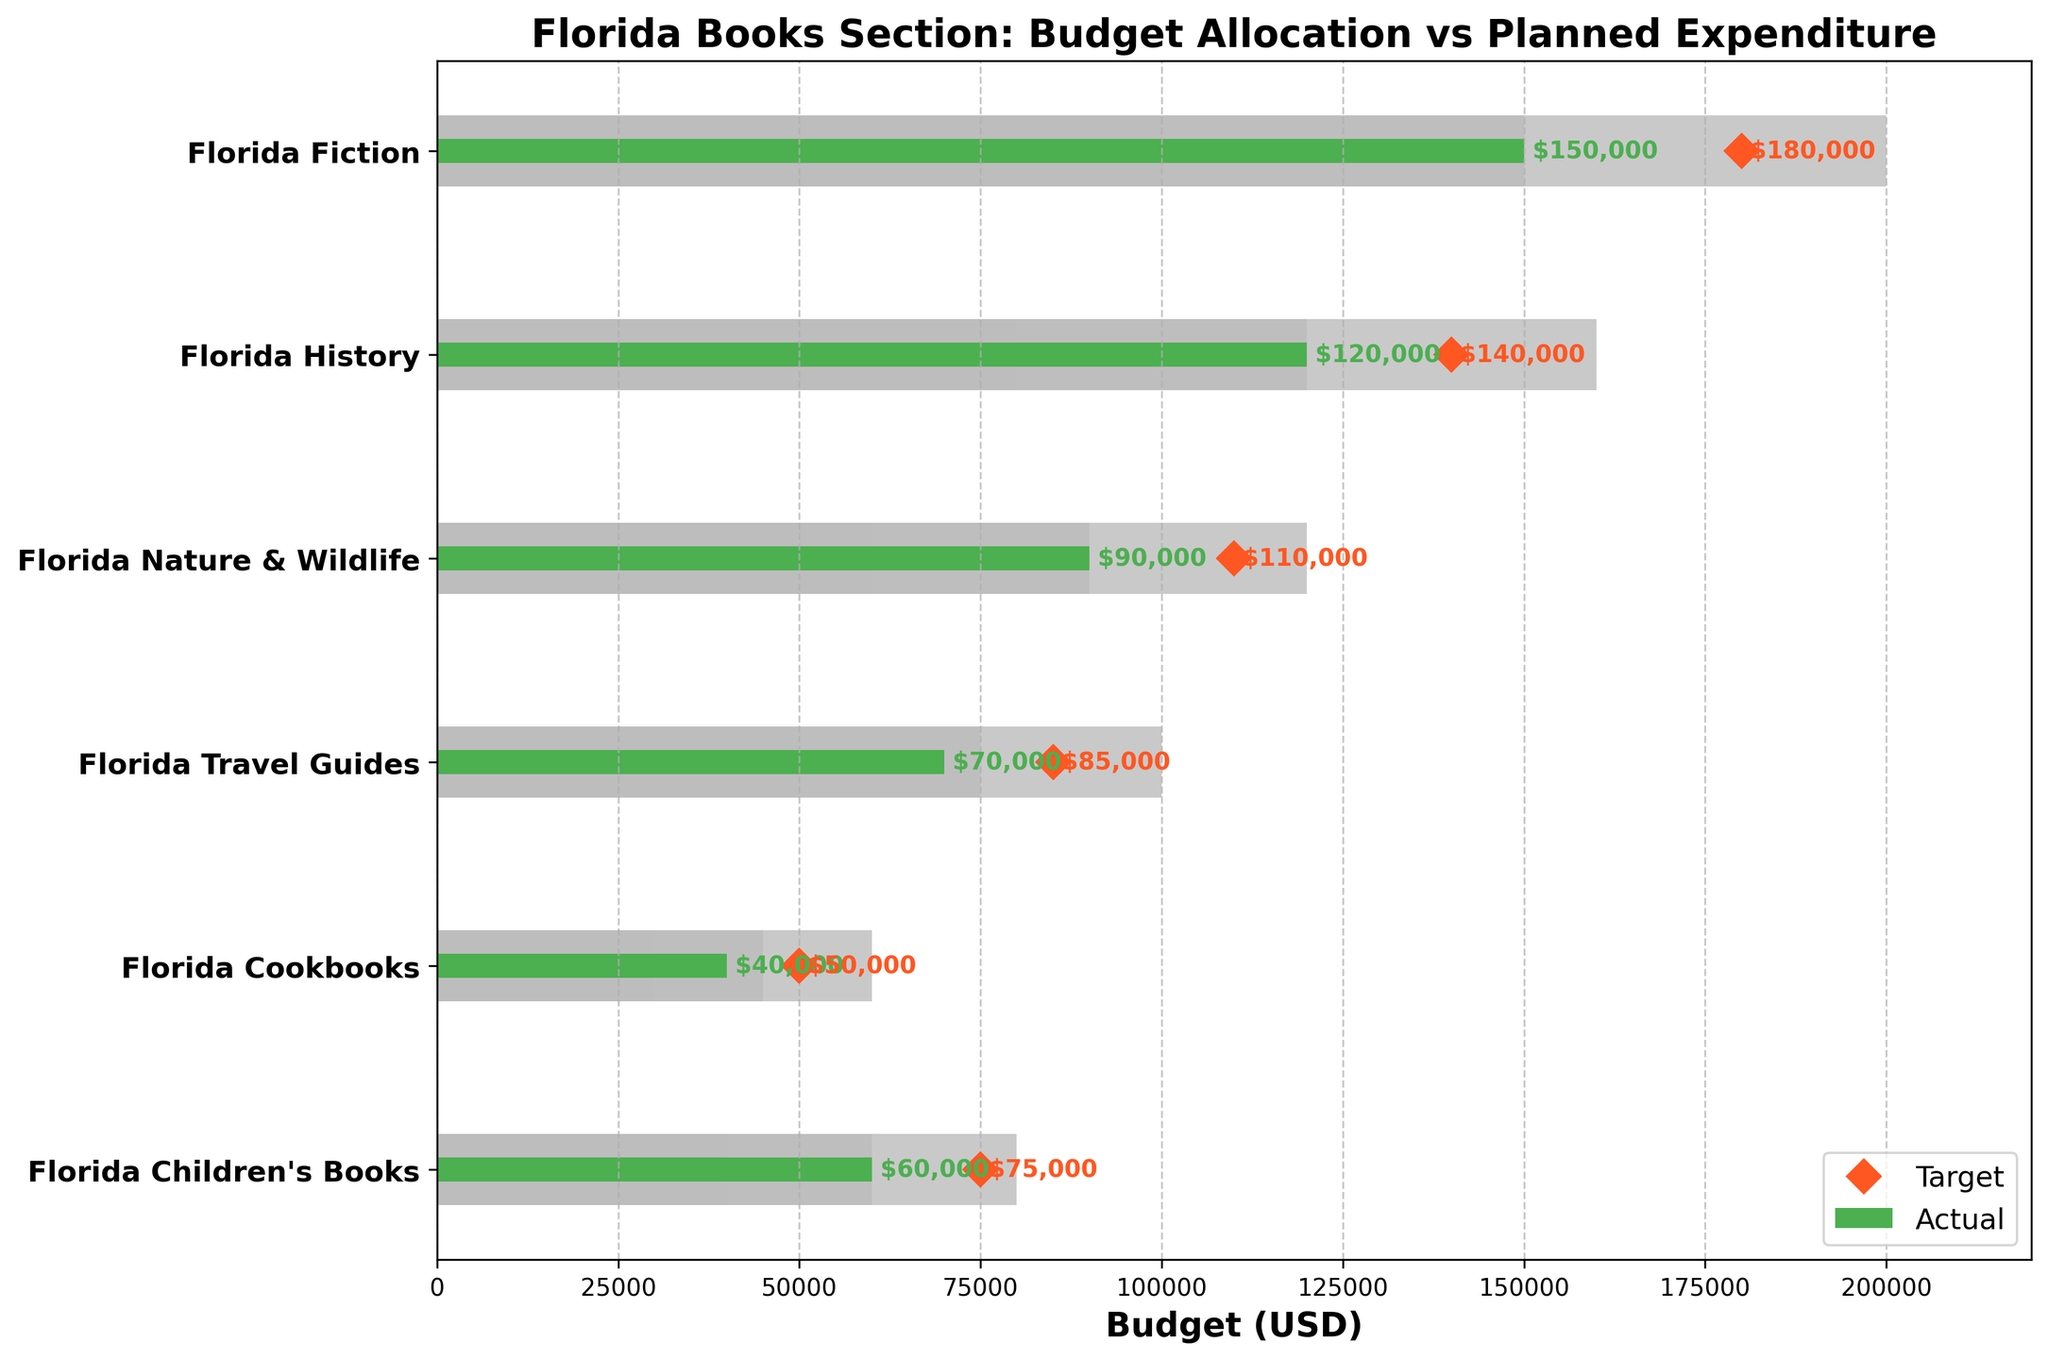What is the title of the chart? The title of the chart is usually displayed at the top of the figure. By looking at the top of the chart, you will see the main title which is often bold and prominent.
Answer: Florida Books Section: Budget Allocation vs Planned Expenditure What is the budget for Florida Children's Books? The budget for each category is represented by a green horizontal bar. Locate the green horizontal bar for "Florida Children's Books" and read the corresponding value.
Answer: $60,000 Which category has the highest target budget? The target budget is represented by a red diamond marker. Identify the category with the highest red diamond markers.
Answer: Florida Fiction What is the difference between the target and actual budget for Florida Cookbooks? The target budget for each category is represented by the red diamond marker, and the actual budget is represented by the green bar. Subtract the actual budget value from the target budget value for the "Florida Cookbooks" category.
Answer: $10,000 How many categories have their actual budgets exceeding the first range (Range1)? The first range is the segment shaded with the lightest grey color. Count all categories where the actual budget, represented by the green bar, extends beyond the lightest grey segment.
Answer: Five For which categories is the actual budget higher than the target budget? The green bar must be longer than and to the right of the red diamond marker for those categories. Identify these categories by checking which green bars surpass their respective red diamond markers.
Answer: None Compare the actual budgets of Florida History and Florida Travel Guides. Which one is higher? Locate the green bars for both "Florida History" and "Florida Travel Guides" and compare their lengths. The one with the longer green bar has the higher actual budget.
Answer: Florida History What is the total actual budget for all categories combined? Sum all the values represented by the green bars for each category.
Answer: $530,000 How does the actual budget for Florida Nature & Wildlife compare to its target budget? Compare the green bar value to the red diamond marker value for "Florida Nature & Wildlife". Indicate whether the actual budget is less than, greater than, or equal to the target budget.
Answer: Less than What colors represent the different budget ranges and what do they signify? The different budget ranges are represented by shades of grey:
- The lightest grey represents Range1 (expected minimum budget).
- The medium grey represents Range2 (midrange budget).
- The darkest grey represents Range3 (maximum expected budget).
Answer: Light grey: Range1, Medium grey: Range2, Dark grey: Range3 